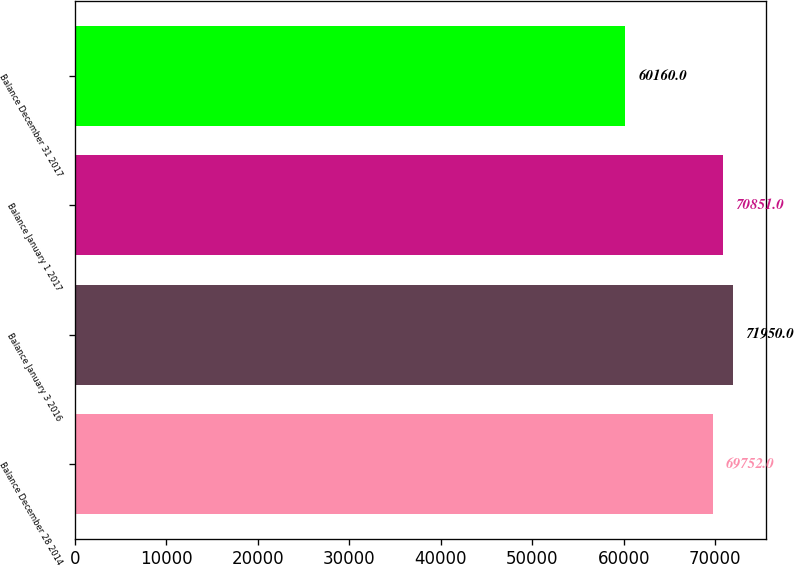<chart> <loc_0><loc_0><loc_500><loc_500><bar_chart><fcel>Balance December 28 2014<fcel>Balance January 3 2016<fcel>Balance January 1 2017<fcel>Balance December 31 2017<nl><fcel>69752<fcel>71950<fcel>70851<fcel>60160<nl></chart> 